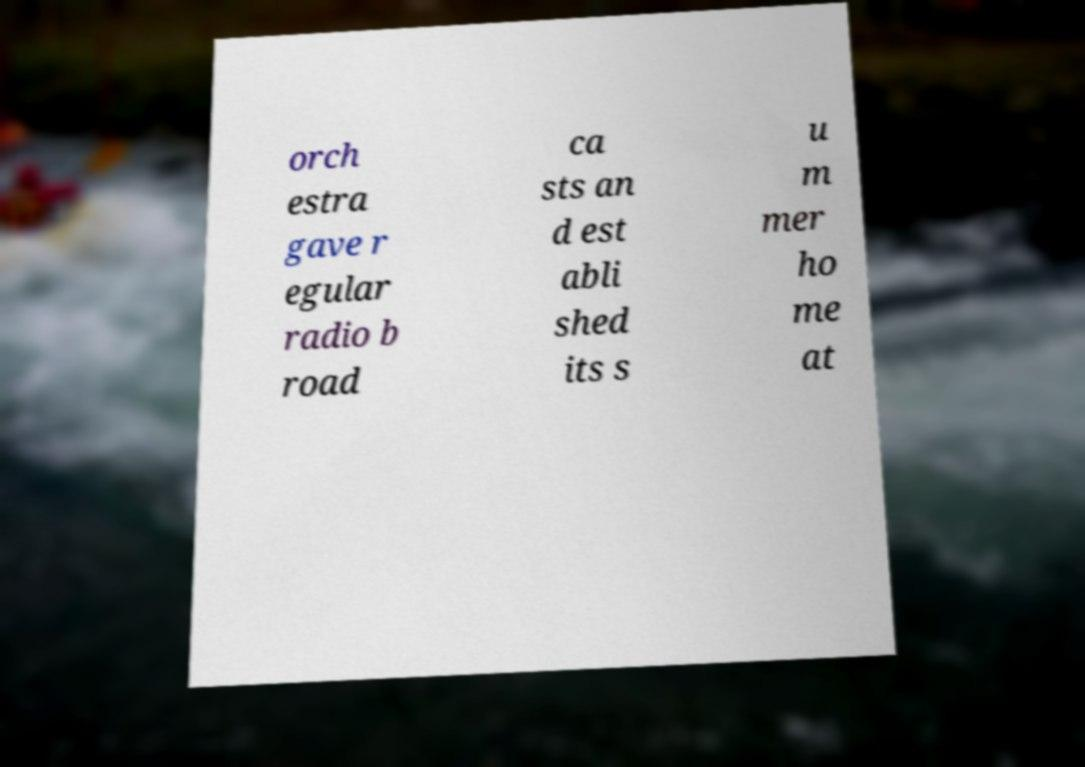For documentation purposes, I need the text within this image transcribed. Could you provide that? orch estra gave r egular radio b road ca sts an d est abli shed its s u m mer ho me at 